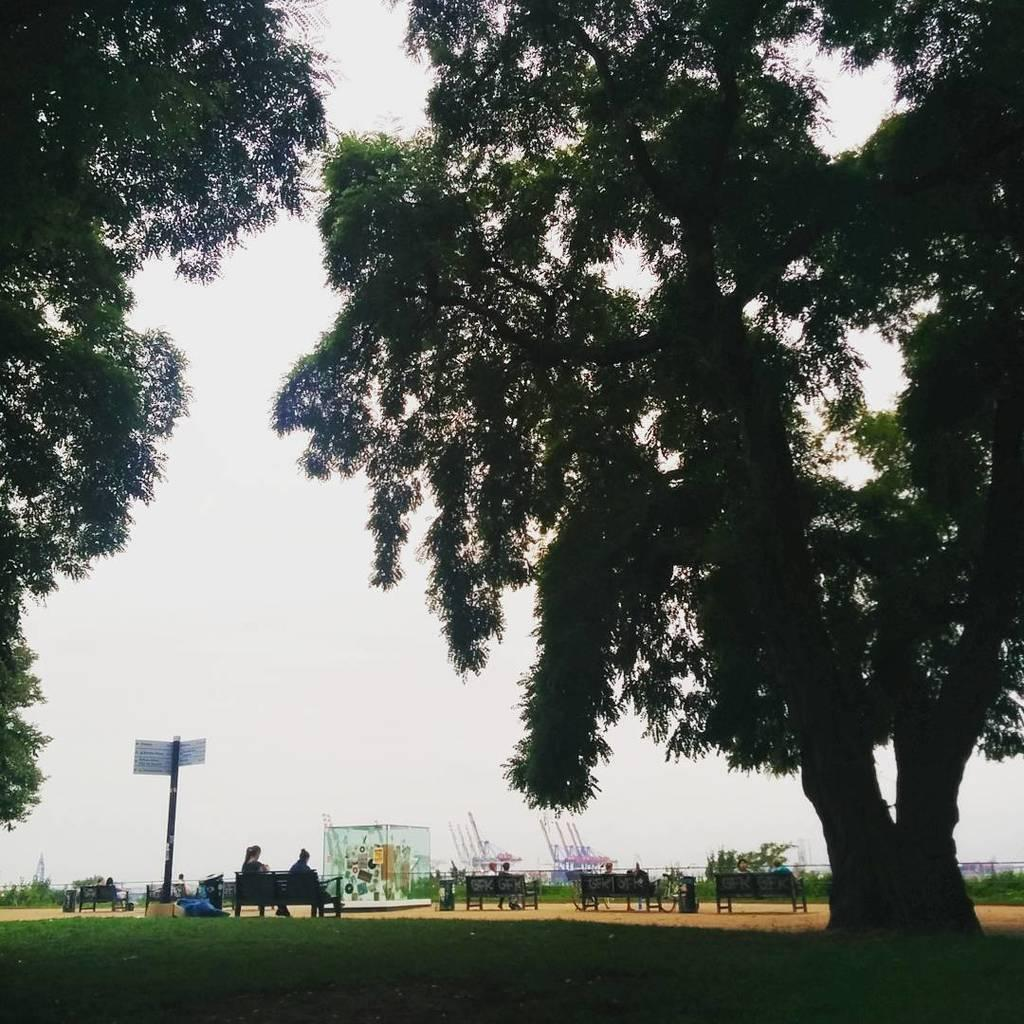What type of vegetation can be seen in the image? There are trees in the image. What are the people in the image doing? There are people sitting on benches in the image. What can be seen on the sign board in the image? The content of the sign board is not mentioned, but it is present in the image. What is visible in the sky in the image? The sky is visible in the image. What type of ground surface is at the bottom of the image? There is grass at the bottom of the image. What is the price of the sheet hanging on the tree in the image? There is no sheet hanging on a tree in the image. Can you tell me how many swings are present in the image? There is no mention of swings in the image; it features trees, people sitting on benches, a sign board, the sky, and grass. 